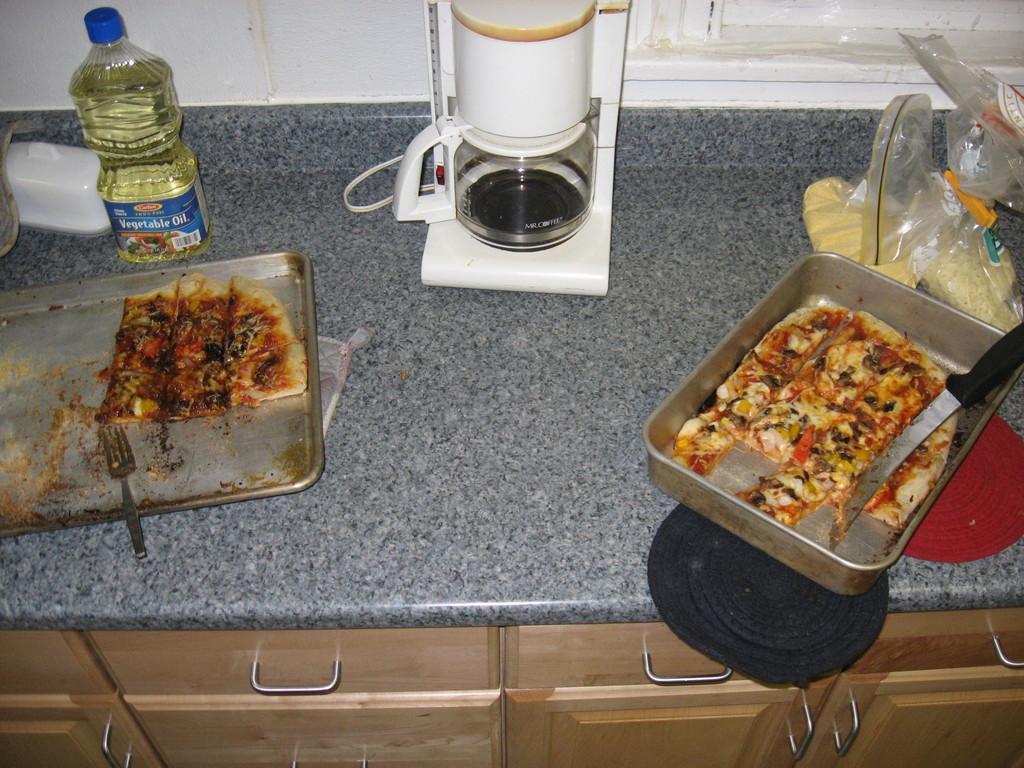Can you describe this image briefly? There are some eatables,mixer and oil on the table. 